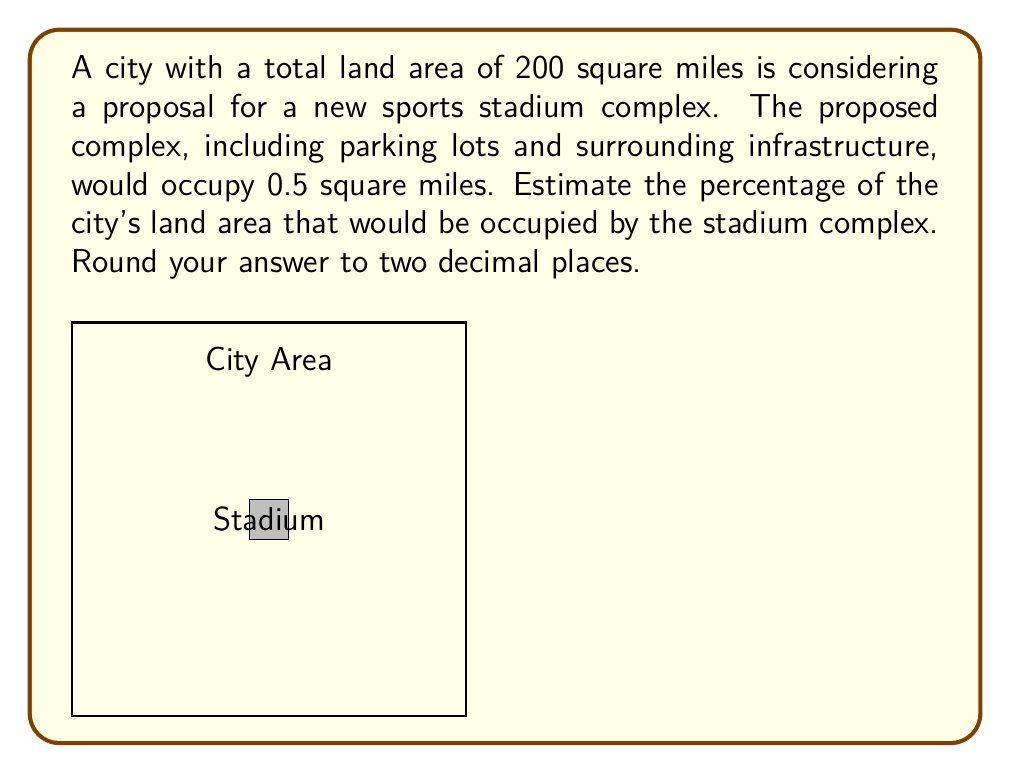Show me your answer to this math problem. To solve this problem, we need to follow these steps:

1. Identify the given information:
   - Total city land area: 200 square miles
   - Proposed stadium complex area: 0.5 square miles

2. Calculate the percentage of land area occupied by the stadium complex:
   - Percentage = (Area of stadium complex / Total city area) × 100
   
   $$\text{Percentage} = \frac{\text{Stadium area}}{\text{City area}} \times 100$$
   
   $$\text{Percentage} = \frac{0.5 \text{ sq miles}}{200 \text{ sq miles}} \times 100$$
   
   $$\text{Percentage} = 0.0025 \times 100 = 0.25\%$$

3. Round the result to two decimal places:
   0.25% (already in two decimal places)

This calculation shows that the proposed stadium complex would occupy a relatively small fraction of the city's total land area. However, from an economic perspective, it's important to consider not just the land use, but also the opportunity cost of using public funds for such a project versus alternative uses that might generate more sustainable economic benefits for the city.
Answer: 0.25% 